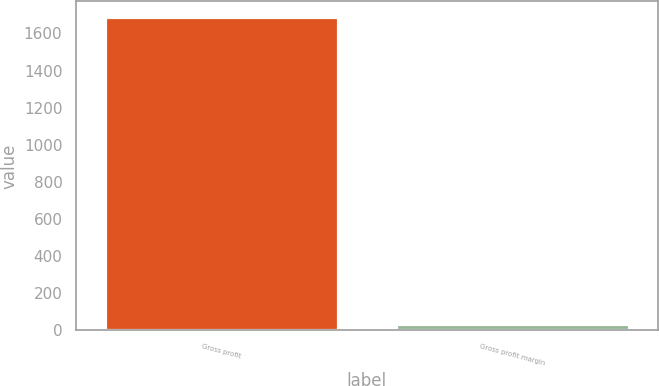Convert chart to OTSL. <chart><loc_0><loc_0><loc_500><loc_500><bar_chart><fcel>Gross profit<fcel>Gross profit margin<nl><fcel>1688.1<fcel>34.1<nl></chart> 